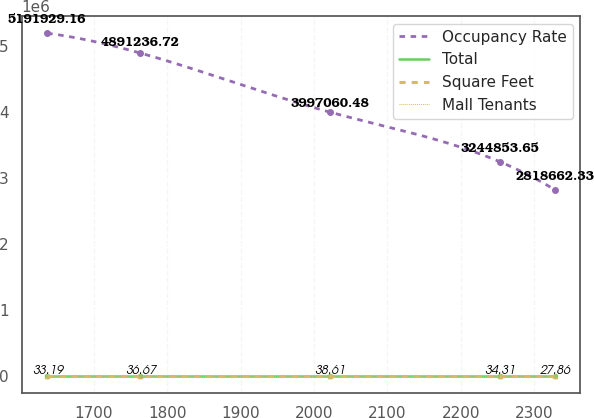Convert chart. <chart><loc_0><loc_0><loc_500><loc_500><line_chart><ecel><fcel>Occupancy Rate<fcel>Total<fcel>Square Feet<fcel>Mall Tenants<nl><fcel>1636.04<fcel>5.19193e+06<fcel>109.09<fcel>33.19<fcel>18.67<nl><fcel>1763.14<fcel>4.89124e+06<fcel>112.46<fcel>36.67<fcel>15.66<nl><fcel>2021.39<fcel>3.99706e+06<fcel>77.19<fcel>38.61<fcel>17.21<nl><fcel>2253.35<fcel>3.24485e+06<fcel>80.56<fcel>34.31<fcel>18.11<nl><fcel>2328.59<fcel>2.81866e+06<fcel>96.89<fcel>27.86<fcel>16<nl></chart> 